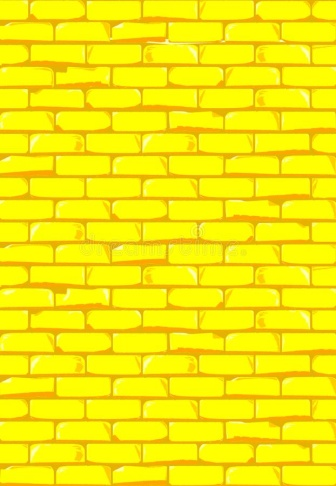What could the choice of the yellow color for this brick wall symbolize or suggest in terms of aesthetics or cultural significance? The vibrant yellow hue of the brick wall could symbolize warmth, positivity, and creativity. In aesthetic terms, such a color makes the structure stand out and can inject a sense of energy and vibrancy into the area. Culturally, yellow often represents joy and happiness in many cultures, suggesting that the building might aim to convey a welcoming and joyful atmosphere. 